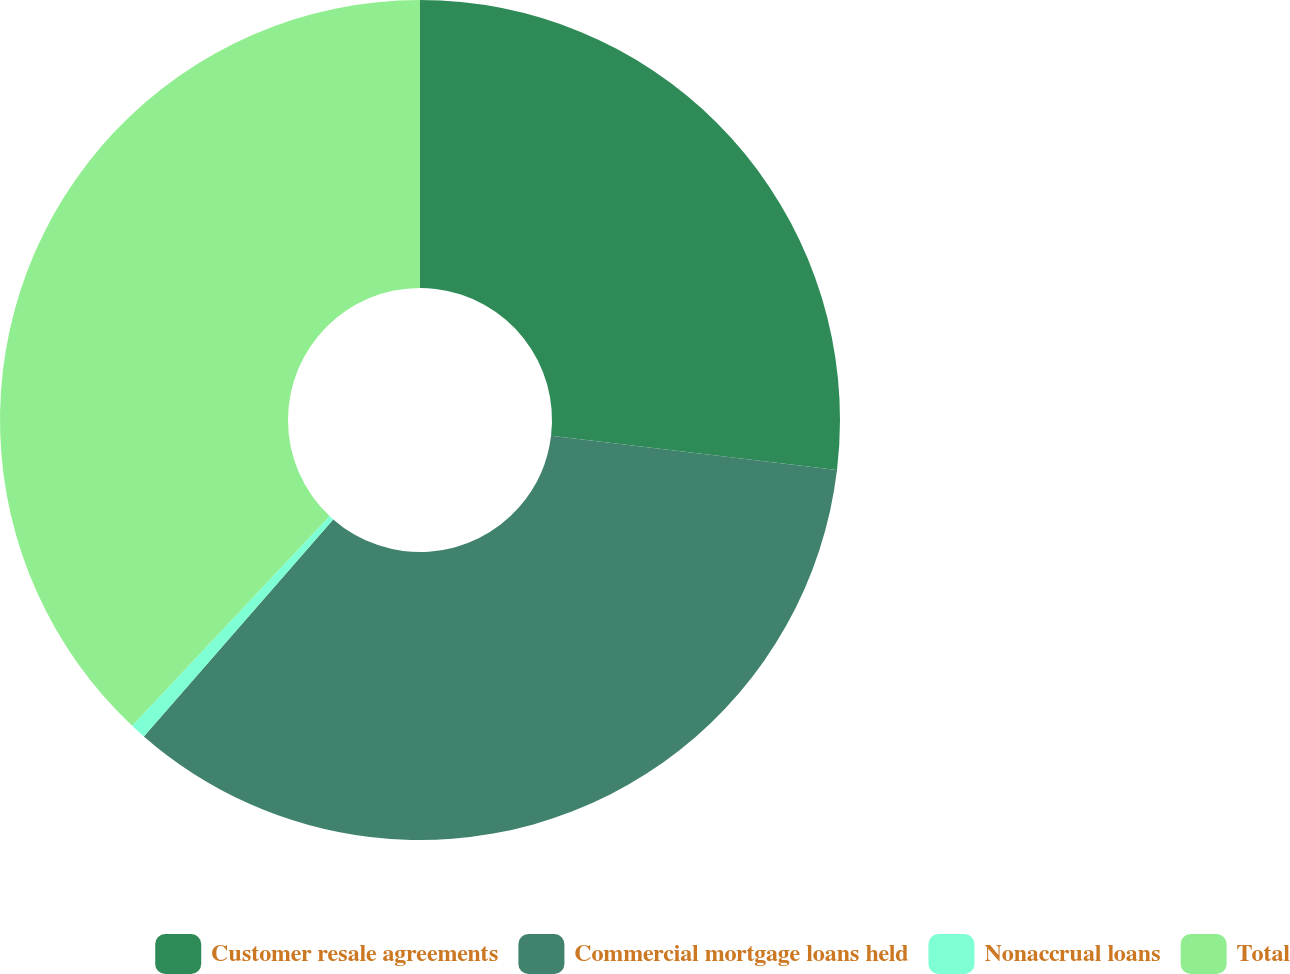Convert chart to OTSL. <chart><loc_0><loc_0><loc_500><loc_500><pie_chart><fcel>Customer resale agreements<fcel>Commercial mortgage loans held<fcel>Nonaccrual loans<fcel>Total<nl><fcel>26.9%<fcel>34.52%<fcel>0.6%<fcel>37.98%<nl></chart> 